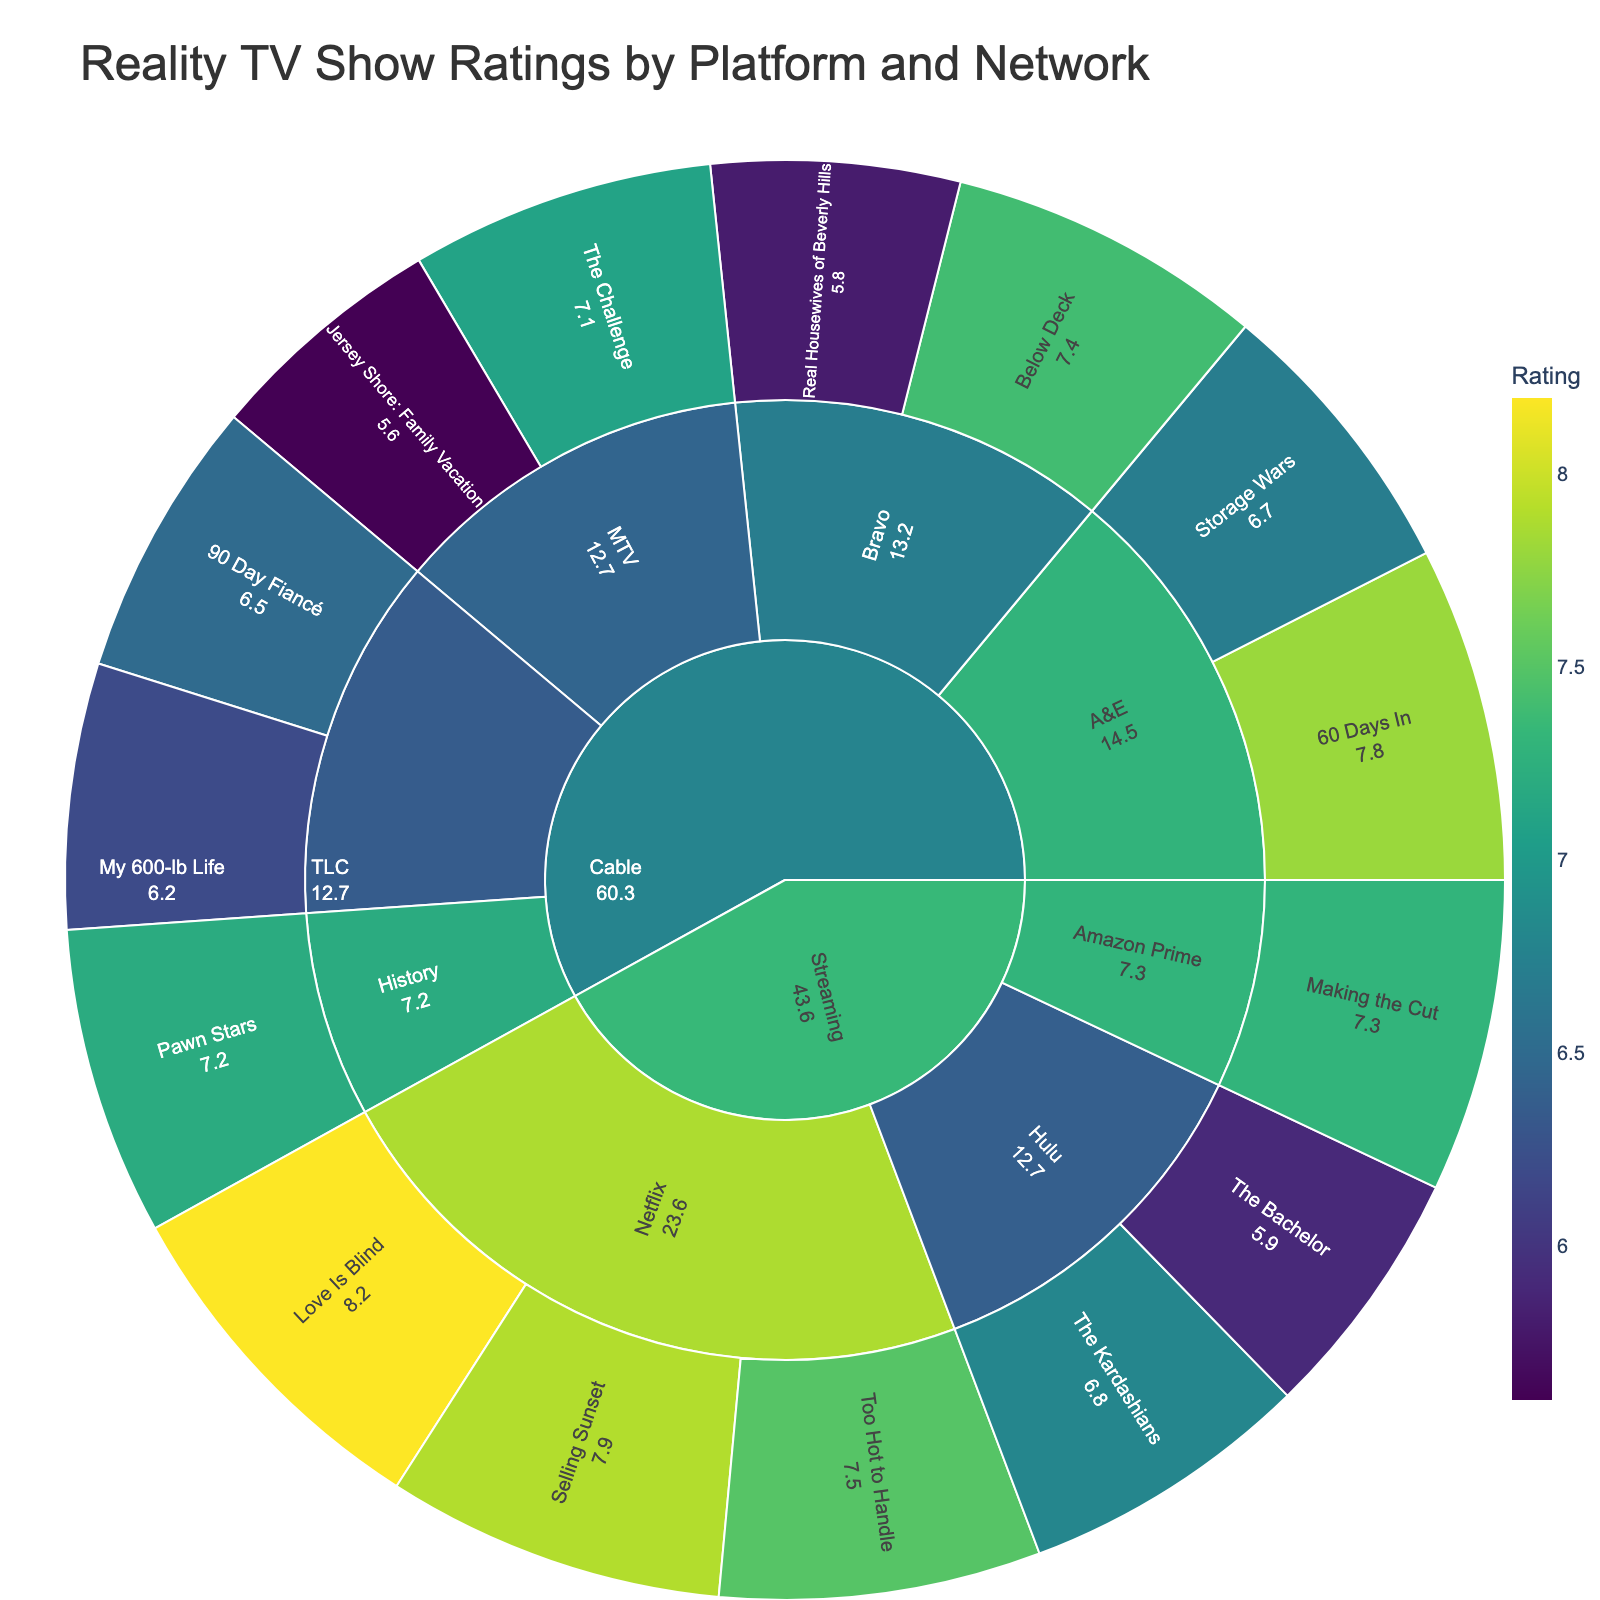what is the highest-rated show on streaming platforms? From the plot, you can see that the outermost ring represents shows, and the highest rating is marked by the color intensity. On streaming platforms, "Love Is Blind" on Netflix has the highest rating with 8.2.
Answer: Love Is Blind What is the title of the plot? The title of the plot is prominently displayed at the top of the figure. It reads "Reality TV Show Ratings by Platform and Network."
Answer: Reality TV Show Ratings by Platform and Network Which streaming platform has the highest-rated show? The highest-rated show is "Love Is Blind" with a rating of 8.2, and it is on the streaming platform Netflix, as indicated in the plot.
Answer: Netflix What's the average rating of the shows on Hulu? The shows on Hulu are "The Kardashians" and "The Bachelor," with ratings 6.8 and 5.9 respectively. The average rating is calculated as (6.8 + 5.9) / 2 = 6.35.
Answer: 6.35 Which has more high-rated shows, streaming platforms or cable networks? Compare the number of shows with a rating above a certain threshold, say 7.0, on both platforms. From the plot, Netflix and Hulu in streaming have "Love Is Blind" (8.2), "Too Hot to Handle" (7.5), "Selling Sunset" (7.9), and "Making the Cut" (7.3). For cable networks, "Below Deck" (7.4), "The Challenge" (7.1), and "60 Days In" (7.8) are above 7.0. Streaming has 5, while cable has 3 above 7.0.
Answer: Streaming platforms How do the ratings of shows on Bravo compare to those on TLC? On Bravo, the shows "Real Housewives of Beverly Hills" and "Below Deck" have ratings of 5.8 and 7.4, respectively. On TLC, "90 Day Fiancé" and "My 600-lb Life" have ratings of 6.5 and 6.2, respectively. Therefore, the average rating for Bravo is (5.8 + 7.4) / 2 = 6.6, and for TLC it's (6.5 + 6.2) / 2 = 6.35. Bravo has a slightly higher average rating.
Answer: Bravo What is the total number of shows rated in the figure? Count all the individual shows listed in the plot. For streaming: Netflix (3), Hulu (2), Amazon Prime (1). For cable: TLC (2), Bravo (2), MTV (2), A&E (2), History (1). The total is 3 + 2 + 1 + 2 + 2 + 2 + 2 + 1 = 15.
Answer: 15 Which network on cable has the highest average show rating? Calculate the average ratings for each network: TLC (6.5 + 6.2) / 2 = 6.35, Bravo (5.8 + 7.4) / 2 = 6.6, MTV (5.6 + 7.1) / 2 = 6.35, A&E (6.7 + 7.8) / 2 = 7.25, History (7.2). Thus, A&E has the highest average rating of 7.25.
Answer: A&E What's the rating of the show with the median value among all listed shows? First, list out all ratings: 8.2, 7.9, 7.8, 7.5, 7.4, 7.3, 7.2, 7.1, 6.8, 6.7, 6.5, 6.2, 5.9, 5.8, 5.6. The median is the middle value in this ordered list, which is 7.2.
Answer: 7.2 Which platform has the lowest-rated show, and what is its rating? "The Bachelor" on Hulu and "Jersey Shore: Family Vacation" on MTV both have a rating of 5.6, the lowest discussed shows.
Answer: Hulu and MTV 